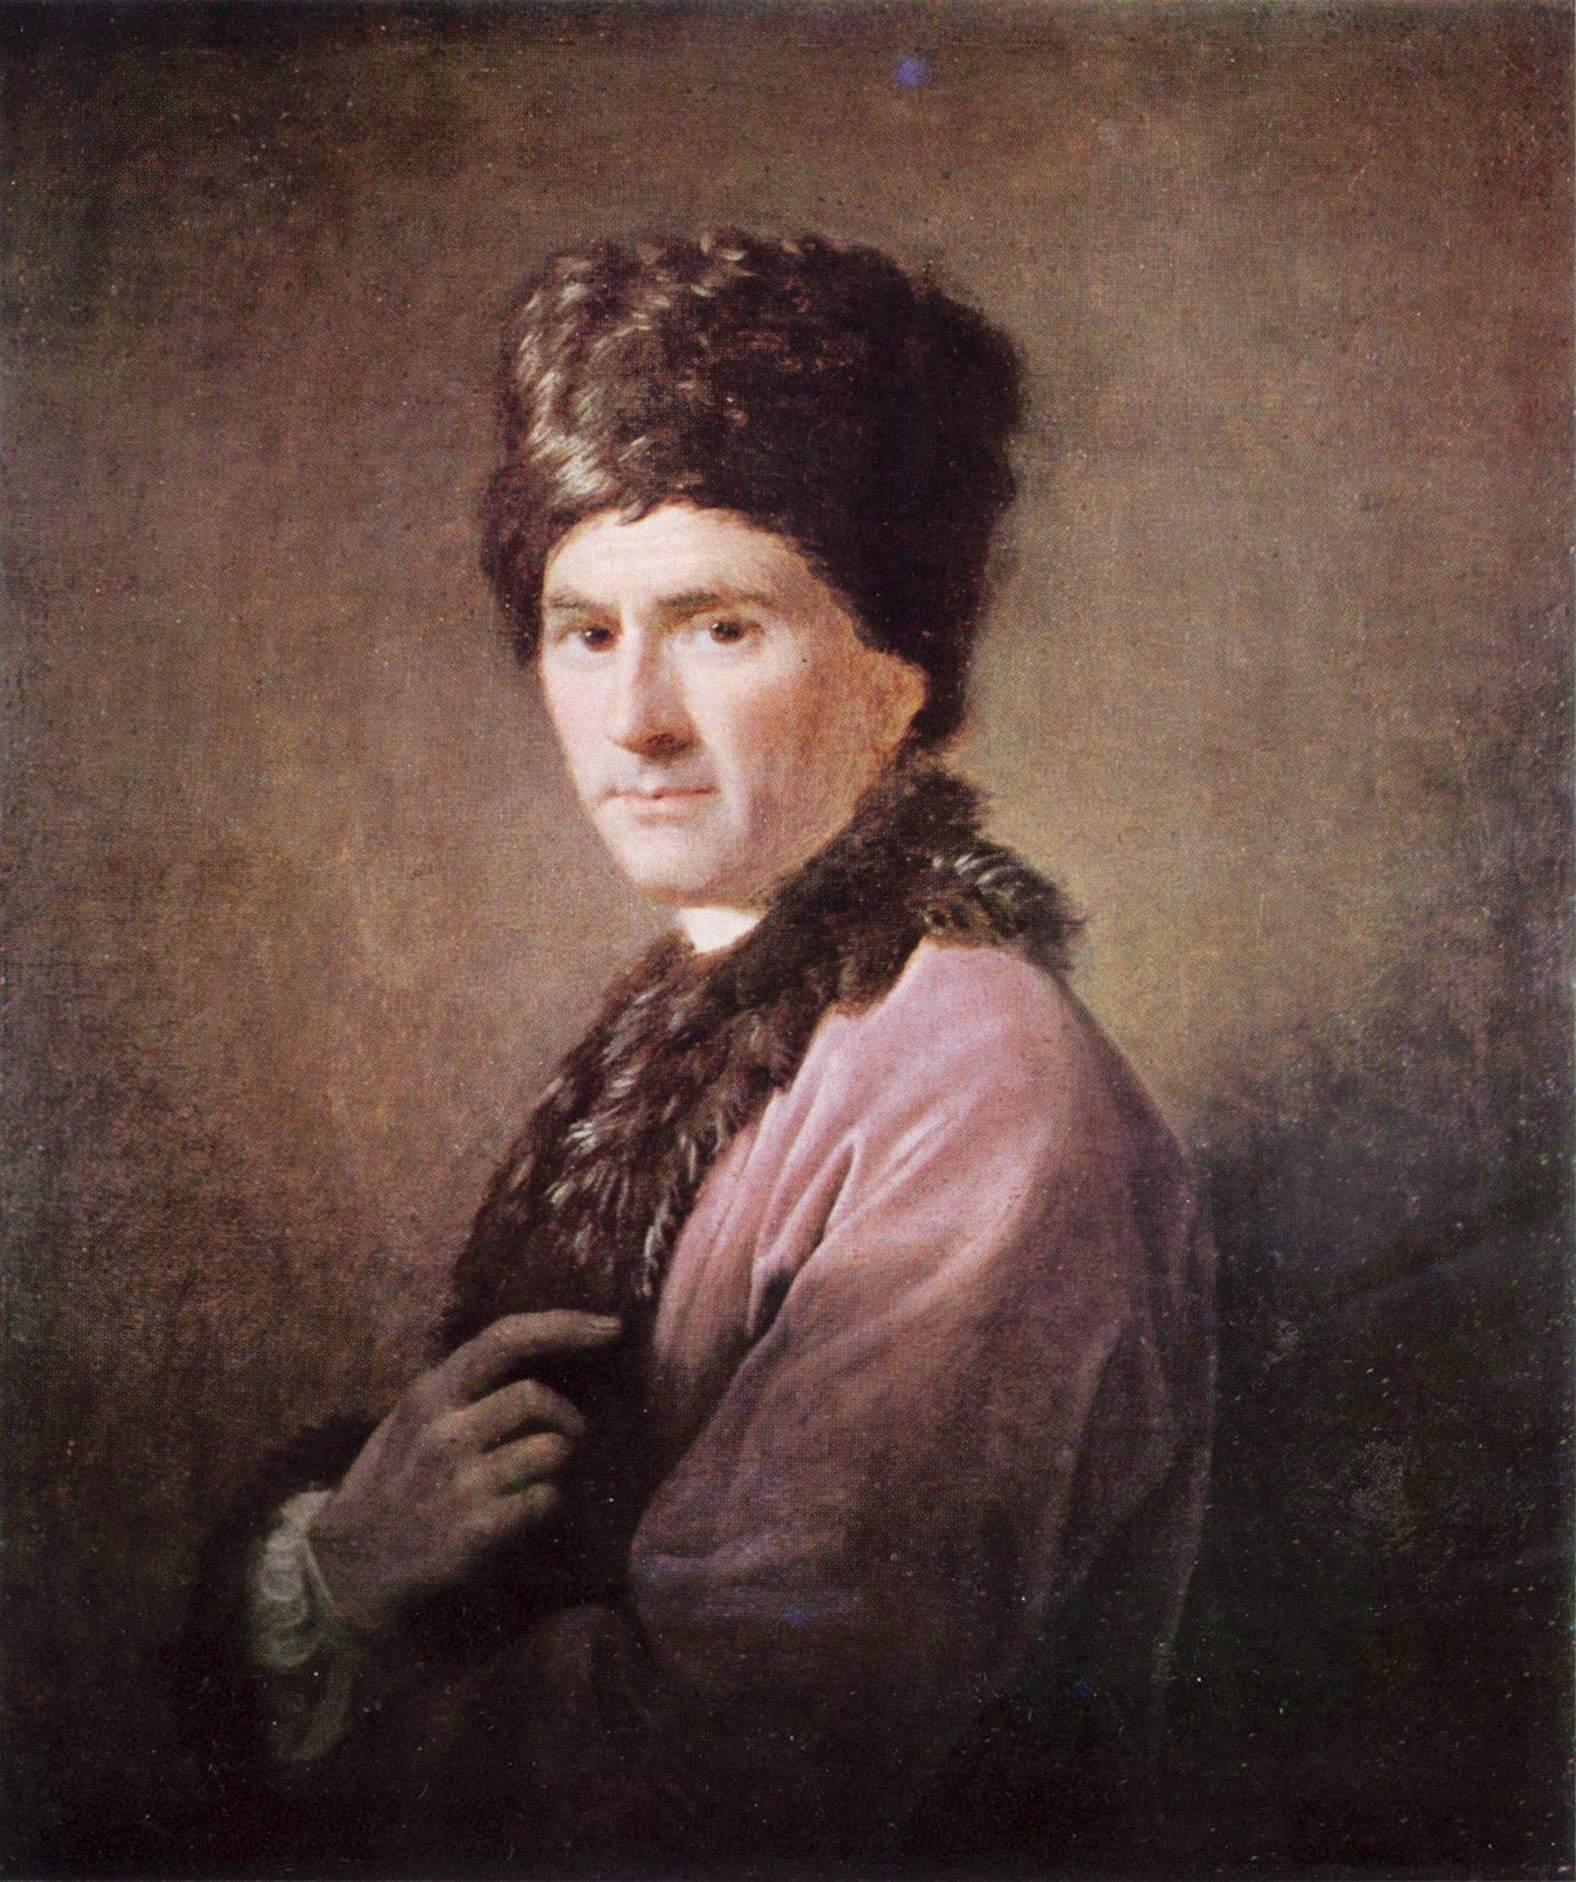How would you interpret the use of color and light in this painting? The artist's use of color and light in this painting serves to draw the viewer's attention to the central figure. The choice of a subdued, almost monochromatic palette for the background puts the focus firmly on the vividness of the pink coat and the contrasting texture of the fur. The lighting, predominantly illuminating the left side of the face, the coat, and the hat, creates a dramatic effect emphasizing the three-dimensionality of the figure. Such use of chiaroscuro, the contrast between light and dark, adds a sculptural quality to the portrait and spotlights the fine details of the subject's facial features and the luxurious materials of his attire. 